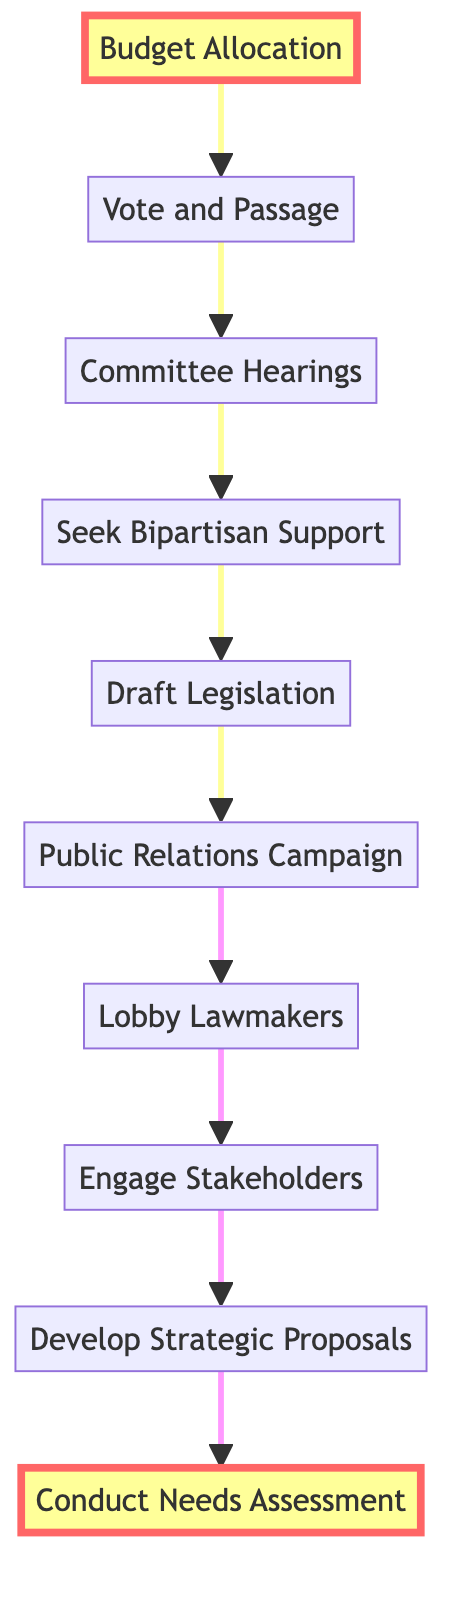What is the first step in the diagram? The first step in the diagram, which is at the bottom, is "Conduct Needs Assessment" as it is the starting point of the flow.
Answer: Conduct Needs Assessment What step comes immediately after "Engage Stakeholders"? The step that comes immediately after "Engage Stakeholders" is "Lobby Lawmakers", indicating the direct progression in the process.
Answer: Lobby Lawmakers How many total steps are outlined in the diagram? By counting all distinct steps in the flow chart, we find there are ten total steps, ranging from "Conduct Needs Assessment" to "Budget Allocation."
Answer: 10 What is the last step in the funding process? The last step in the funding process, which is at the top of the diagram, is "Budget Allocation," signifying the final action in the flow.
Answer: Budget Allocation What are the two highlighted steps in the diagram? The two highlighted steps in the diagram are "Conduct Needs Assessment" and "Budget Allocation," indicating they are key stages in securing funding.
Answer: Conduct Needs Assessment, Budget Allocation Which step follows "Draft Legislation"? The step that follows "Draft Legislation" is "Public Relations Campaign," showing the next action in the sequence after drafting.
Answer: Public Relations Campaign What relationship exists between "Vote and Passage" and "Committee Hearings"? The relationship is sequential; "Vote and Passage" directly follows "Committee Hearings," meaning a vote occurs after hearings are held.
Answer: Sequential relationship How does "Seek Bipartisan Support" relate to "Lobby Lawmakers"? "Seek Bipartisan Support" comes after "Lobby Lawmakers," suggesting that lobbying lawmakers is a prerequisite for building bipartisan support for the funding initiative.
Answer: Prerequisite relationship What is necessary before "Committee Hearings" can occur? Before "Committee Hearings" can occur, "Seek Bipartisan Support" must be undertaken, as it is a direct predecessor step in the flow.
Answer: Seek Bipartisan Support 